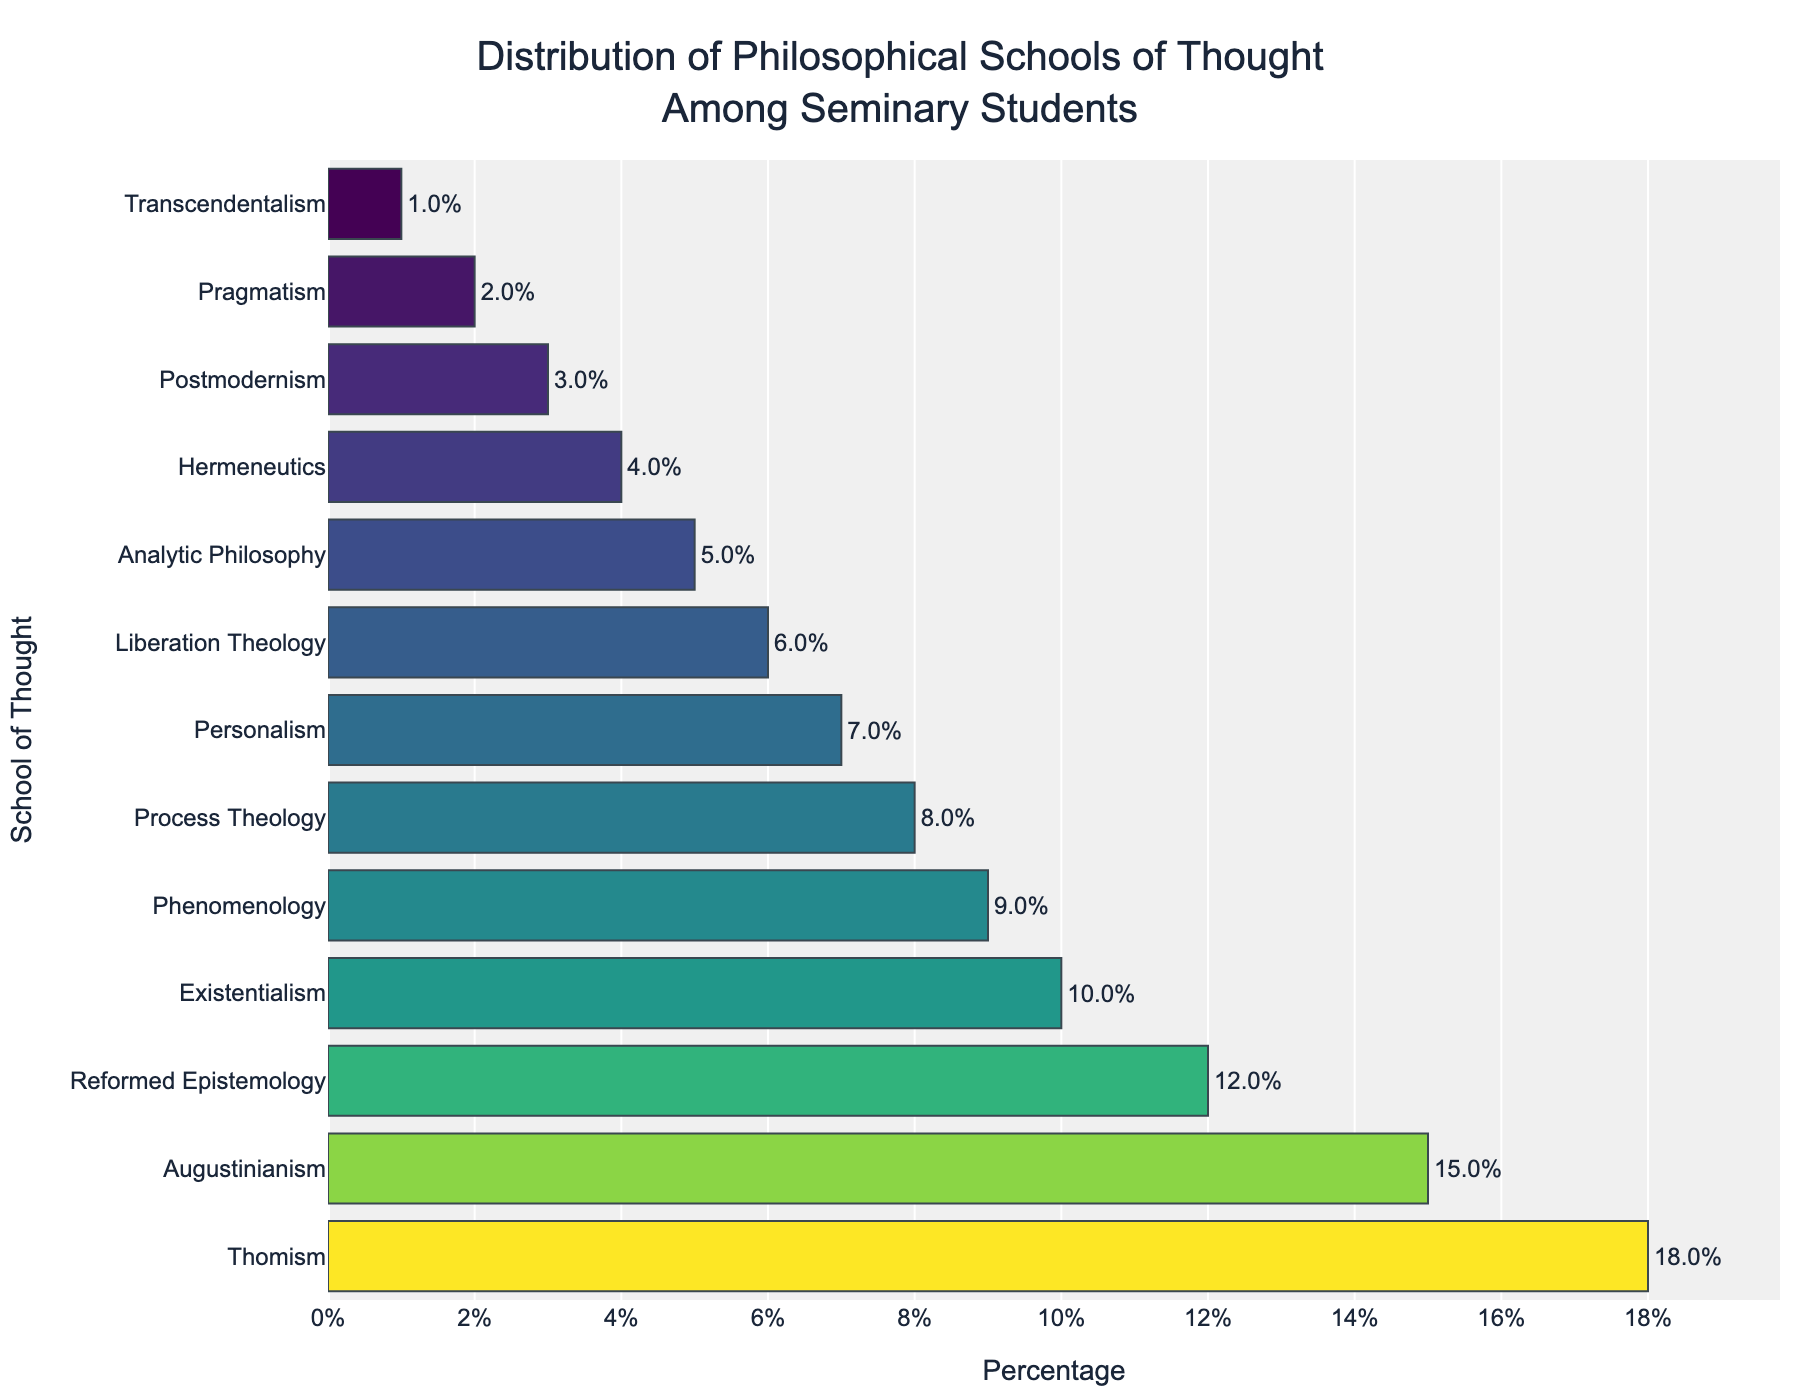Which philosophical school has the highest percentage among seminary students? By examining the bar chart, the top of the chart represents the school with the highest percentage. Thomism is positioned at the top with 18%.
Answer: Thomism Which schools have a percentage less than 5? By scanning the bars with percentages less than 5%, the schools are analytic philosophy, hermeneutics, postmodernism, pragmatism, and transcendentalism.
Answer: Analytic Philosophy, Hermeneutics, Postmodernism, Pragmatism, Transcendentalism What is the combined percentage of Reformed Epistemology and Existentialism? The percentage for Reformed Epistemology is 12%, and for Existentialism, it is 10%. Summing these two numbers gives us 12 + 10 = 22%.
Answer: 22% How many philosophical schools have a percentage of 8% or more? Observing the bars, the schools with percentages of 8% or more are Thomism, Augustinianism, Reformed Epistemology, Existentialism, and Phenomenology. Counting these gives us 5.
Answer: 5 Which school has a percentage closer to 5%, Hermeneutics or Pragmatism? Hermeneutics is at 4% and Pragmatism is at 2%. Hermeneutics at 4% is closer to 5% than Pragmatism at 2%.
Answer: Hermeneutics What is the difference between the highest and the lowest percentages? Thomism has the highest at 18%, and Transcendentalism has the lowest at 1%. The difference is 18 - 1 = 17%.
Answer: 17% Of the schools with less than 10%, which one has the highest percentage? Among the schools with less than 10% (Phenomenology, Process Theology, Personalism, Liberation Theology, Analytic Philosophy, Hermeneutics, Postmodernism, Pragmatism, Transcendentalism), Phenomenology has the highest at 9%.
Answer: Phenomenology What is the average percentage of the bottom three philosophical schools? The bottom three schools are Postmodernism (3%), Pragmatism (2%), and Transcendentalism (1%). The average is (3 + 2 + 1) / 3 = 2%.
Answer: 2% How do the percentages of Process Theology and Personalism compare? Process Theology is at 8% and Personalism is at 7%. Thus, Process Theology has a higher percentage than Personalism.
Answer: Process Theology Which color represents the highest percentage bar? The bar chart uses a Viridis colorscale, which typically colors higher percentages in brighter or more vivid shades. The bar for Thomism, the highest percentage (18%), is the brightest on the chart.
Answer: Bright color 